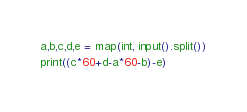Convert code to text. <code><loc_0><loc_0><loc_500><loc_500><_Python_>a,b,c,d,e = map(int, input().split())
print((c*60+d-a*60-b)-e)</code> 